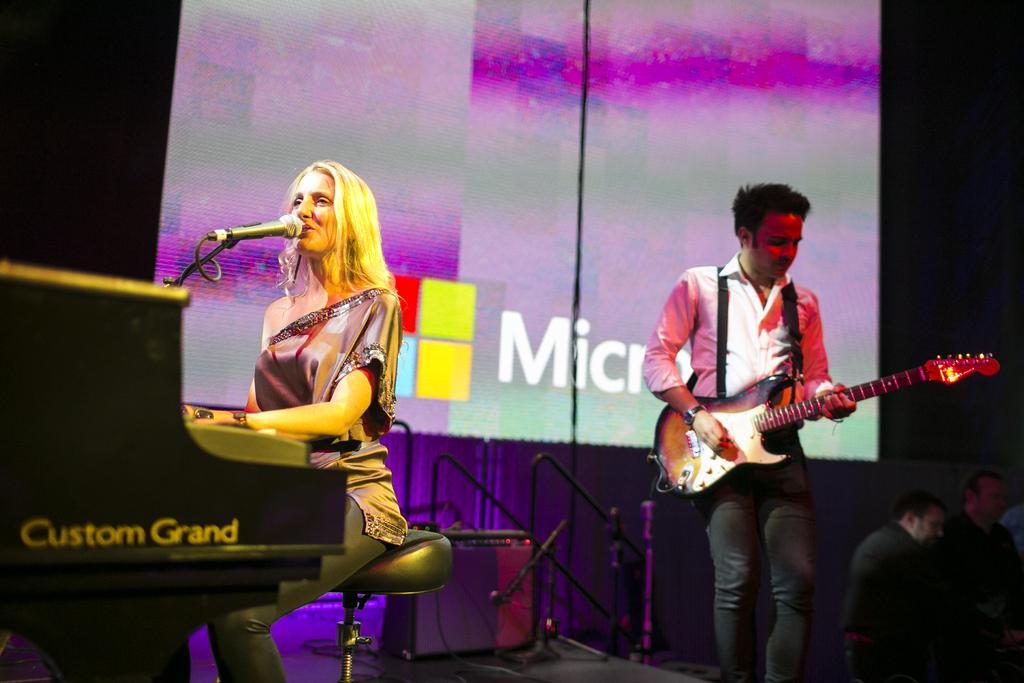Describe this image in one or two sentences. In this image I see a woman who is sitting on the stool and she is in front of a mic. I can also see a man who is holding a guitar. In the background I see a screen and 2 persons over here. 